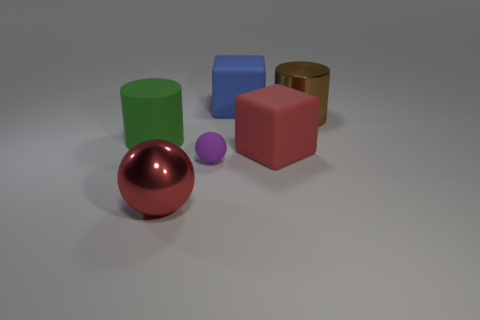Is the size of the metal cylinder the same as the purple ball that is behind the red ball?
Offer a very short reply. No. What is the large block in front of the rubber thing on the left side of the tiny purple matte ball made of?
Give a very brief answer. Rubber. There is a metal thing to the right of the sphere to the right of the metal object on the left side of the purple rubber sphere; how big is it?
Offer a very short reply. Large. There is a tiny purple thing; is it the same shape as the big shiny thing on the right side of the red matte thing?
Your answer should be very brief. No. What is the big red block made of?
Provide a succinct answer. Rubber. How many metal things are either small blue balls or blocks?
Make the answer very short. 0. Is the number of large red shiny things that are to the left of the big rubber cylinder less than the number of large shiny objects left of the red rubber block?
Keep it short and to the point. Yes. There is a big red object that is to the right of the ball that is behind the red metallic thing; are there any big green matte objects that are in front of it?
Your answer should be very brief. No. What material is the big cube that is the same color as the metallic ball?
Offer a terse response. Rubber. There is a large metal object to the left of the large blue object; is its shape the same as the large metallic object that is to the right of the blue matte object?
Your answer should be very brief. No. 